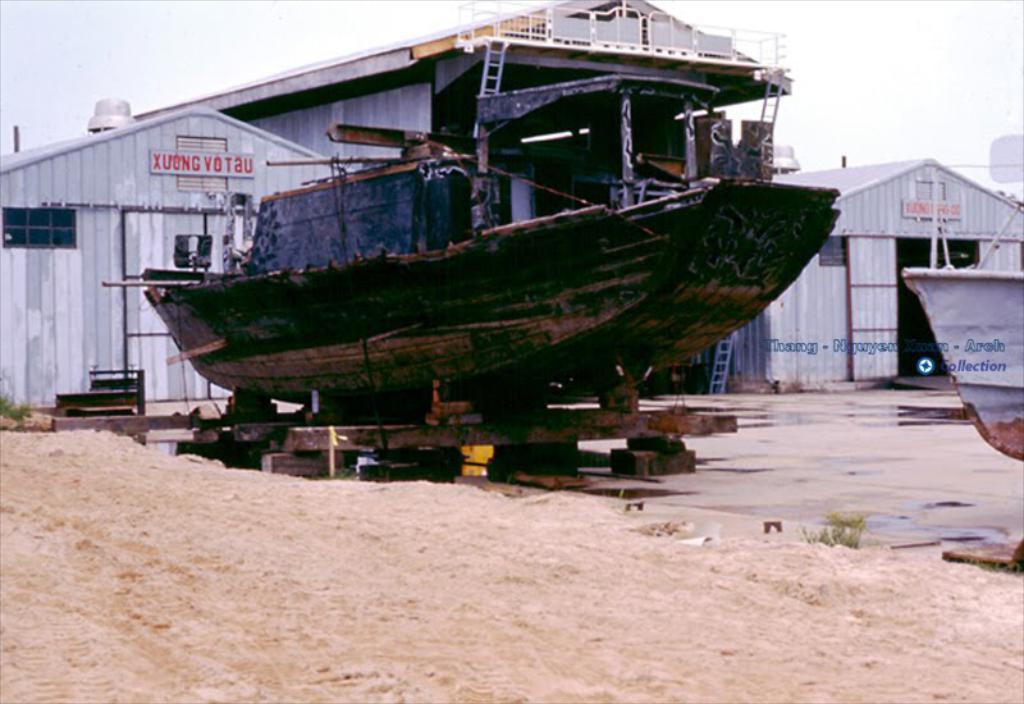Describe this image in one or two sentences. In this picture we can see boats, sand, ladder, grass, houses, name boards and in the background we can see the sky. 